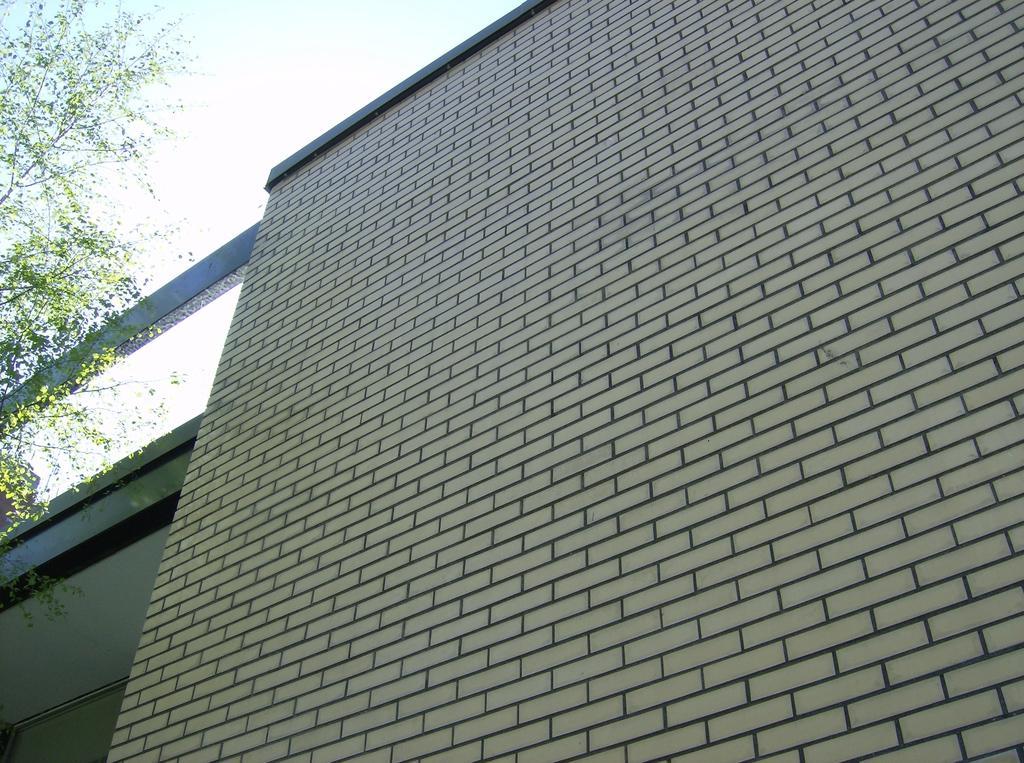Please provide a concise description of this image. In this image there is a building, a tree and the sky. 